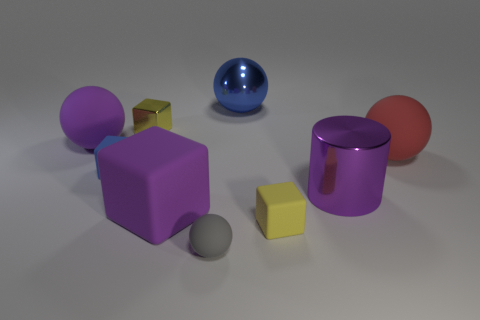Add 1 balls. How many objects exist? 10 Subtract all cylinders. How many objects are left? 8 Add 4 purple cubes. How many purple cubes are left? 5 Add 3 blue metal spheres. How many blue metal spheres exist? 4 Subtract 1 red spheres. How many objects are left? 8 Subtract all tiny metallic objects. Subtract all tiny yellow metallic things. How many objects are left? 7 